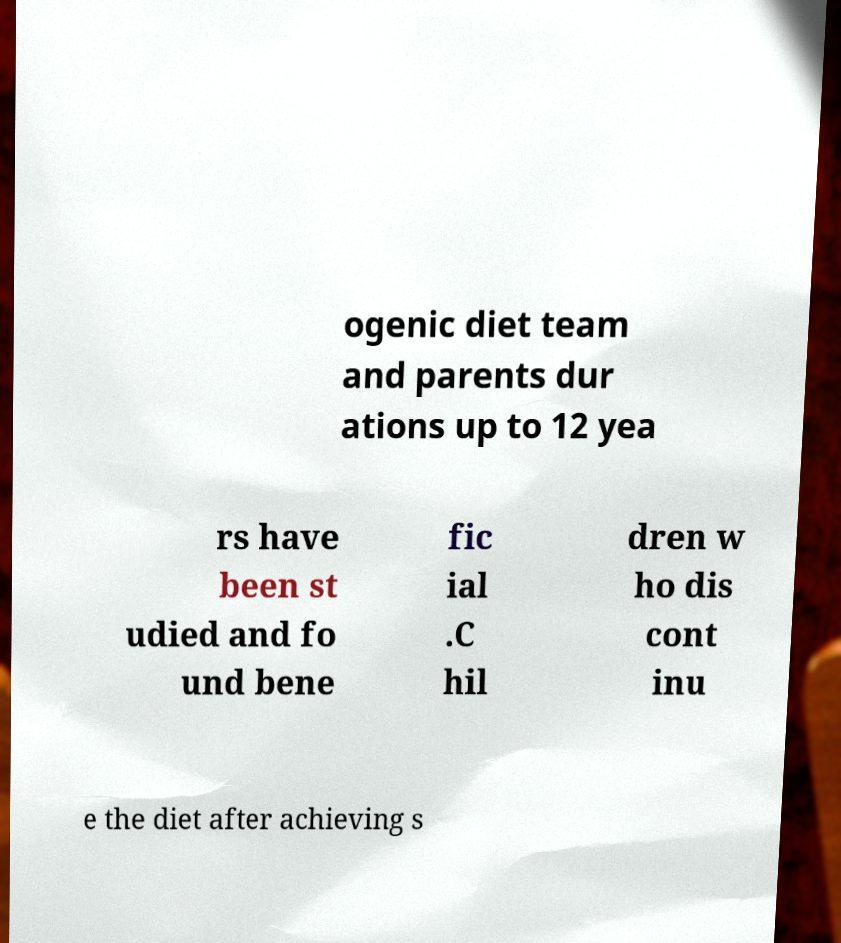Could you assist in decoding the text presented in this image and type it out clearly? ogenic diet team and parents dur ations up to 12 yea rs have been st udied and fo und bene fic ial .C hil dren w ho dis cont inu e the diet after achieving s 